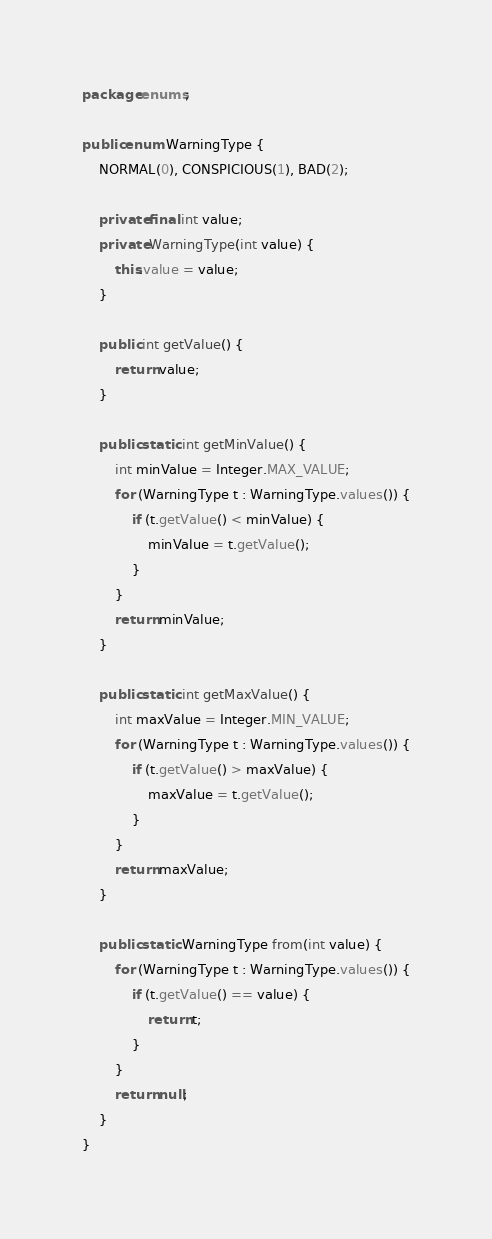<code> <loc_0><loc_0><loc_500><loc_500><_Java_>package enums;

public enum WarningType {
	NORMAL(0), CONSPICIOUS(1), BAD(2);

	private final int value;
	private WarningType(int value) {
		this.value = value;
	}

	public int getValue() {
		return value;
	}

	public static int getMinValue() {
		int minValue = Integer.MAX_VALUE;
		for (WarningType t : WarningType.values()) {
			if (t.getValue() < minValue) {
				minValue = t.getValue();
			}
		}
		return minValue;
	}

	public static int getMaxValue() {
		int maxValue = Integer.MIN_VALUE;
		for (WarningType t : WarningType.values()) {
			if (t.getValue() > maxValue) {
				maxValue = t.getValue();
			}
		}
		return maxValue;
	}

	public static WarningType from(int value) {
		for (WarningType t : WarningType.values()) {
			if (t.getValue() == value) {
				return t;
			}
		}
		return null;
	}
}</code> 